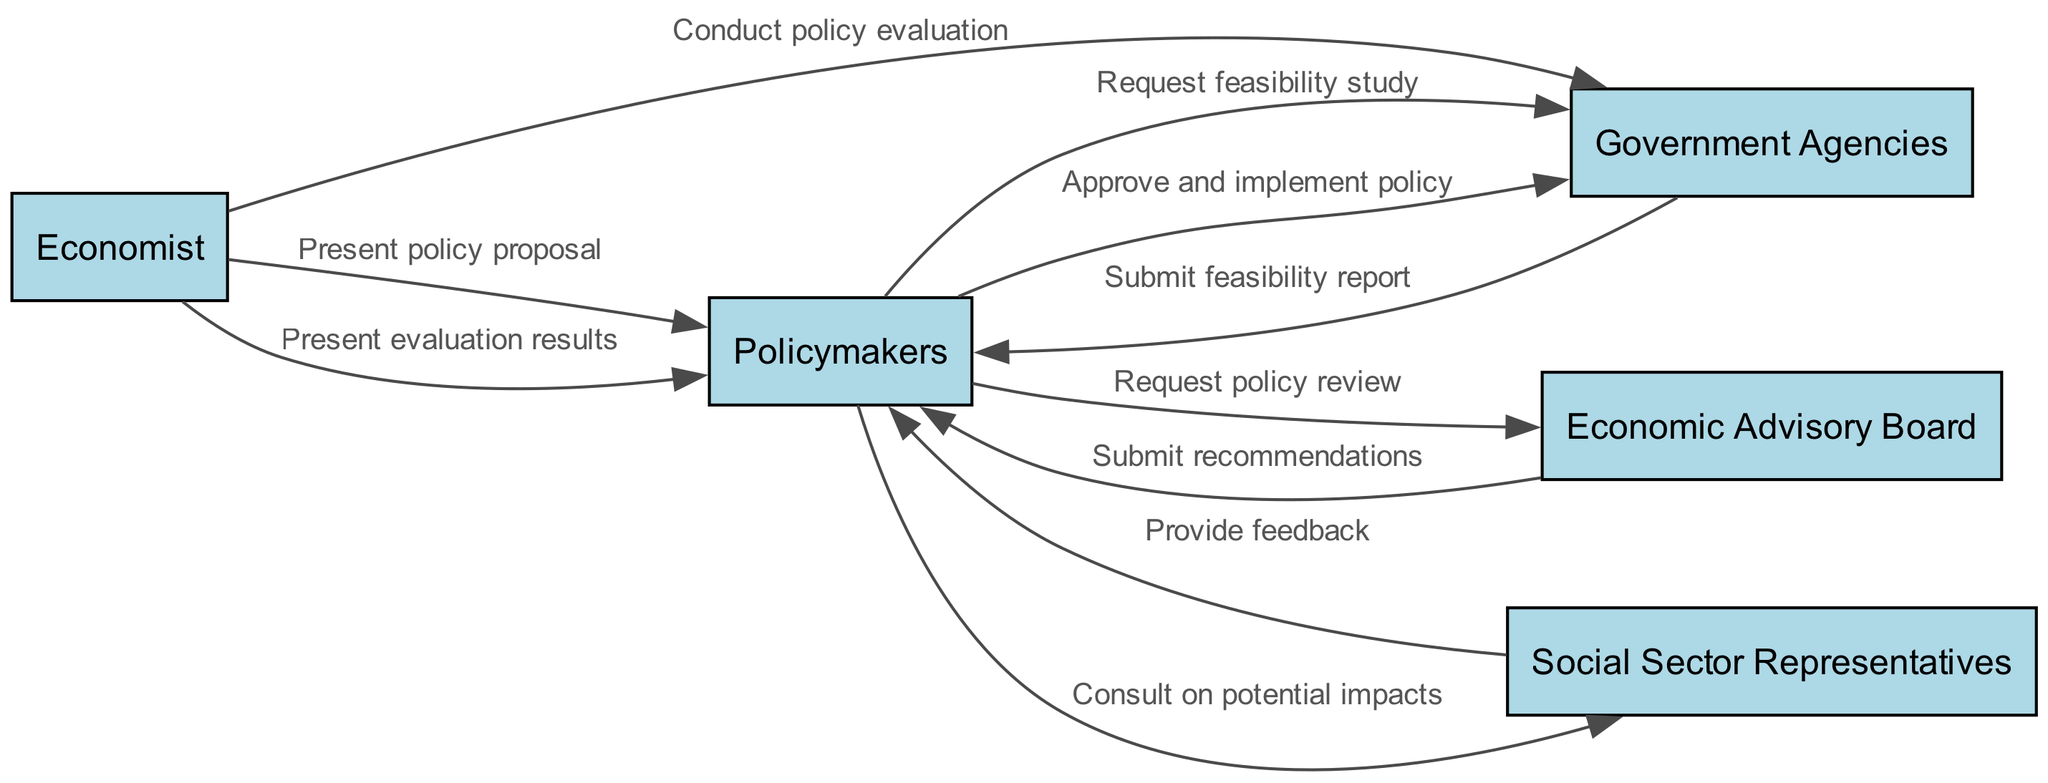What is the total number of actors in the diagram? The diagram lists five distinct actors: Economist, Policymakers, Government Agencies, Social Sector Representatives, and Economic Advisory Board. Therefore, the total number of actors is the count of these distinct entities.
Answer: Five Who requests the feasibility study? The arrow from Policymakers to Government Agencies indicates that it is the Policymakers who send the message to request a feasibility study. This can be directly inferred by looking at the sequence flow.
Answer: Policymakers Which actor provides feedback to the Policymakers? The flow shows that Social Sector Representatives respond to Policymakers with feedback. The sequence clearly indicates this interaction as the one message coming from Social Sector Representatives to Policymakers.
Answer: Social Sector Representatives What is the last step in the implementation process? By following the series of messages, the final interaction depicted is from the Economist presenting evaluation results to the Policymakers. This is the last action that closes the implementation loop.
Answer: Present evaluation results How many messages are sent from the Policymakers? There are a total of five specific messages originating from Policymakers in the sequence. Counting them reveals the frequency of actions taken by Policymakers throughout the process.
Answer: Five What does the Economic Advisory Board submit? The diagram shows a message from the Economic Advisory Board to the Policymakers, which states that the Economic Advisory Board submits recommendations as part of their review process. The wording in the diagram helps identify this specific output.
Answer: Submit recommendations Which two actors are involved in the policy evaluation step? The flow of the diagram reveals that the Economist conducts the policy evaluation, and Government Agencies are involved in this step as they receive the respective action message. This requires identifying both participants from the interaction portrayed.
Answer: Economist and Government Agencies What is the first action taken in the sequence? The initial action in the sequence diagram illustrates that the Economist presents the policy proposal to the Policymakers. This specific flow is clearly marked as the starting point of the entire economic policy process.
Answer: Present policy proposal 